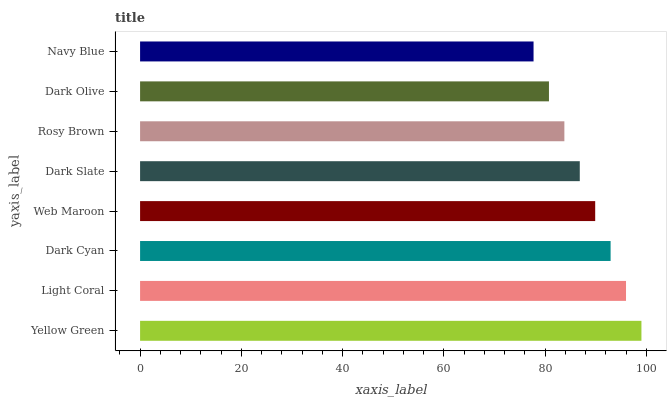Is Navy Blue the minimum?
Answer yes or no. Yes. Is Yellow Green the maximum?
Answer yes or no. Yes. Is Light Coral the minimum?
Answer yes or no. No. Is Light Coral the maximum?
Answer yes or no. No. Is Yellow Green greater than Light Coral?
Answer yes or no. Yes. Is Light Coral less than Yellow Green?
Answer yes or no. Yes. Is Light Coral greater than Yellow Green?
Answer yes or no. No. Is Yellow Green less than Light Coral?
Answer yes or no. No. Is Web Maroon the high median?
Answer yes or no. Yes. Is Dark Slate the low median?
Answer yes or no. Yes. Is Dark Slate the high median?
Answer yes or no. No. Is Rosy Brown the low median?
Answer yes or no. No. 